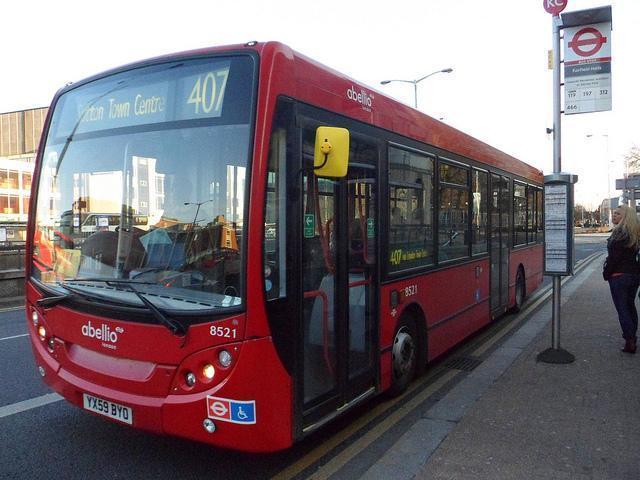How many levels are on the bus?
Give a very brief answer. 1. How many levels is the bus?
Give a very brief answer. 1. How many people can you see?
Give a very brief answer. 1. 